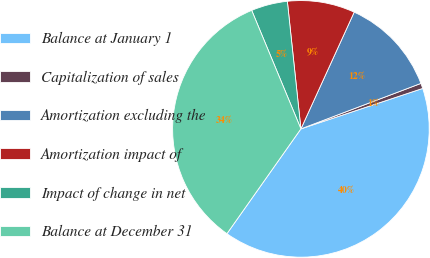Convert chart to OTSL. <chart><loc_0><loc_0><loc_500><loc_500><pie_chart><fcel>Balance at January 1<fcel>Capitalization of sales<fcel>Amortization excluding the<fcel>Amortization impact of<fcel>Impact of change in net<fcel>Balance at December 31<nl><fcel>39.88%<fcel>0.66%<fcel>12.42%<fcel>8.5%<fcel>4.58%<fcel>33.95%<nl></chart> 